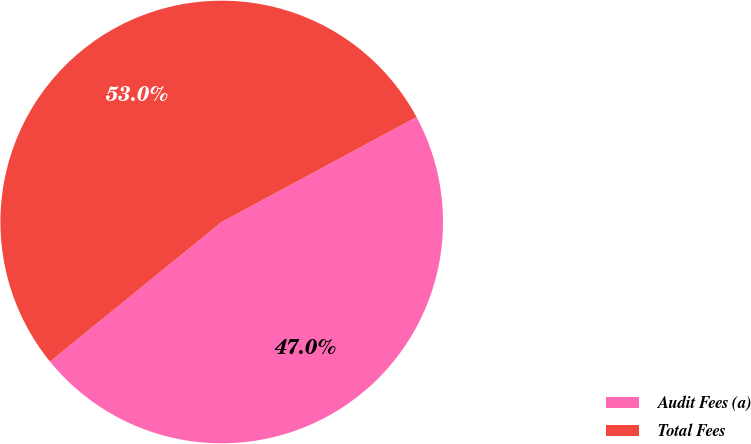<chart> <loc_0><loc_0><loc_500><loc_500><pie_chart><fcel>Audit Fees (a)<fcel>Total Fees<nl><fcel>47.0%<fcel>53.0%<nl></chart> 